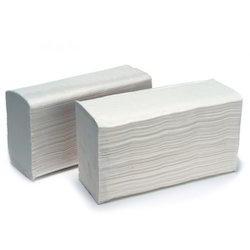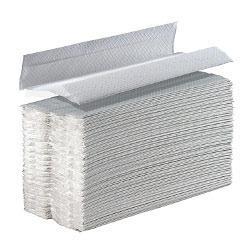The first image is the image on the left, the second image is the image on the right. Considering the images on both sides, is "At least one image shows an upright roll of white towels on a stand." valid? Answer yes or no. No. The first image is the image on the left, the second image is the image on the right. For the images shown, is this caption "In one image, a stack of folded paper towels is angled so the narrow end of the stack is visible, and one paper towel is displayed partially opened." true? Answer yes or no. Yes. 